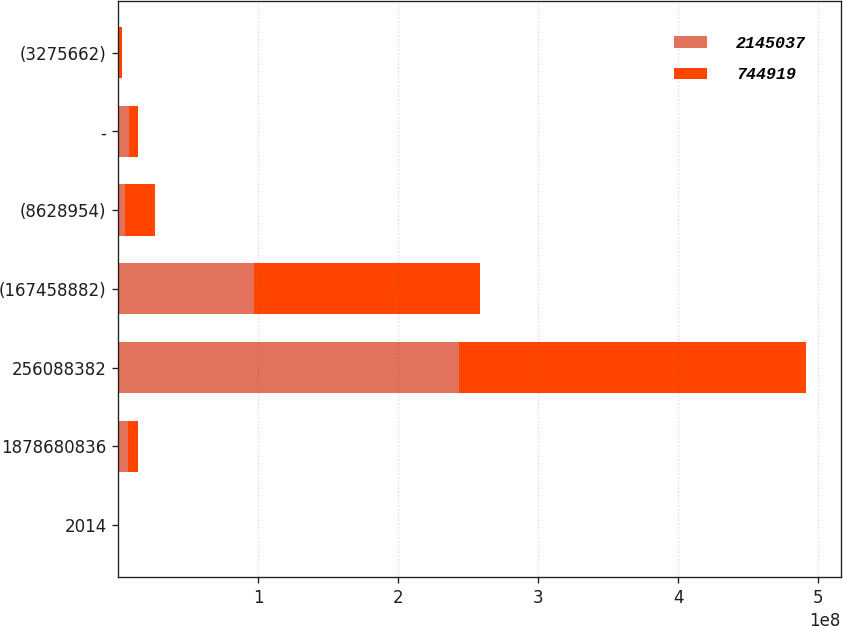Convert chart. <chart><loc_0><loc_0><loc_500><loc_500><stacked_bar_chart><ecel><fcel>2014<fcel>1878680836<fcel>256088382<fcel>(167458882)<fcel>(8628954)<fcel>-<fcel>(3275662)<nl><fcel>2.14504e+06<fcel>2013<fcel>6.96685e+06<fcel>2.43011e+08<fcel>9.69153e+07<fcel>4.78084e+06<fcel>7.3511e+06<fcel>744919<nl><fcel>744919<fcel>2012<fcel>6.96685e+06<fcel>2.48427e+08<fcel>1.61515e+08<fcel>2.17118e+07<fcel>6.58261e+06<fcel>2.14504e+06<nl></chart> 